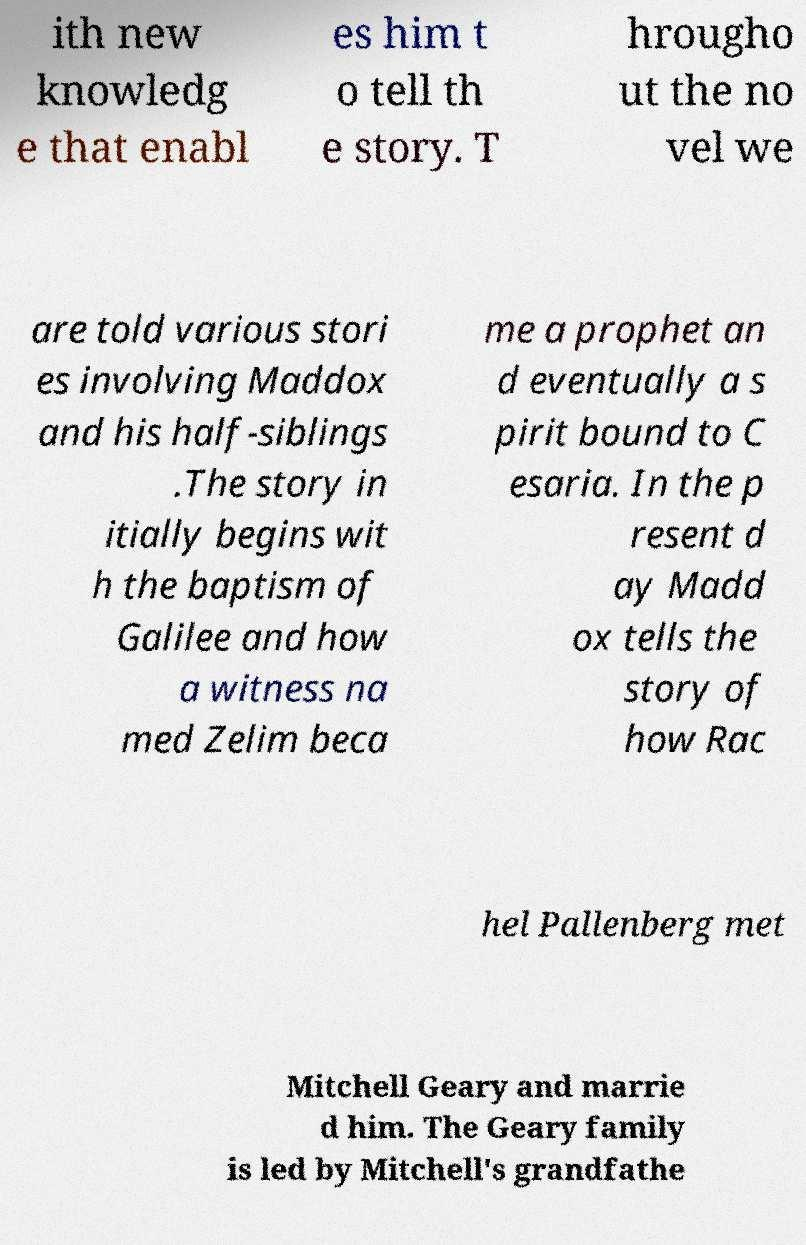Please identify and transcribe the text found in this image. ith new knowledg e that enabl es him t o tell th e story. T hrougho ut the no vel we are told various stori es involving Maddox and his half-siblings .The story in itially begins wit h the baptism of Galilee and how a witness na med Zelim beca me a prophet an d eventually a s pirit bound to C esaria. In the p resent d ay Madd ox tells the story of how Rac hel Pallenberg met Mitchell Geary and marrie d him. The Geary family is led by Mitchell's grandfathe 